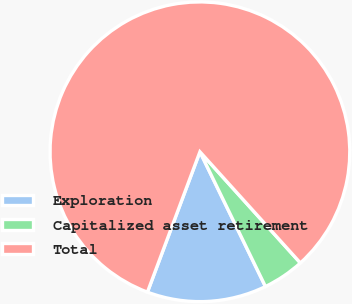Convert chart. <chart><loc_0><loc_0><loc_500><loc_500><pie_chart><fcel>Exploration<fcel>Capitalized asset retirement<fcel>Total<nl><fcel>12.9%<fcel>4.49%<fcel>82.61%<nl></chart> 